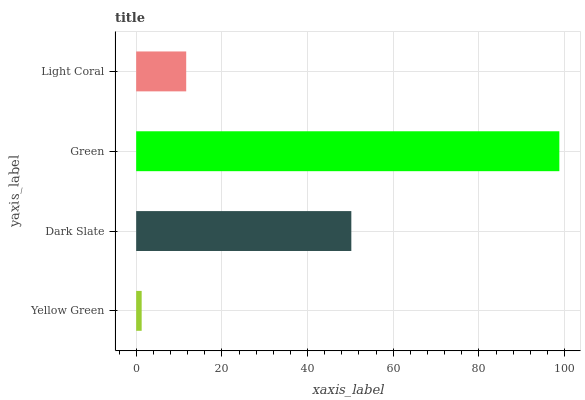Is Yellow Green the minimum?
Answer yes or no. Yes. Is Green the maximum?
Answer yes or no. Yes. Is Dark Slate the minimum?
Answer yes or no. No. Is Dark Slate the maximum?
Answer yes or no. No. Is Dark Slate greater than Yellow Green?
Answer yes or no. Yes. Is Yellow Green less than Dark Slate?
Answer yes or no. Yes. Is Yellow Green greater than Dark Slate?
Answer yes or no. No. Is Dark Slate less than Yellow Green?
Answer yes or no. No. Is Dark Slate the high median?
Answer yes or no. Yes. Is Light Coral the low median?
Answer yes or no. Yes. Is Yellow Green the high median?
Answer yes or no. No. Is Yellow Green the low median?
Answer yes or no. No. 